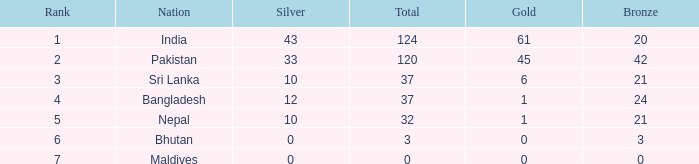Which Silver has a Rank of 6, and a Bronze smaller than 3? None. 